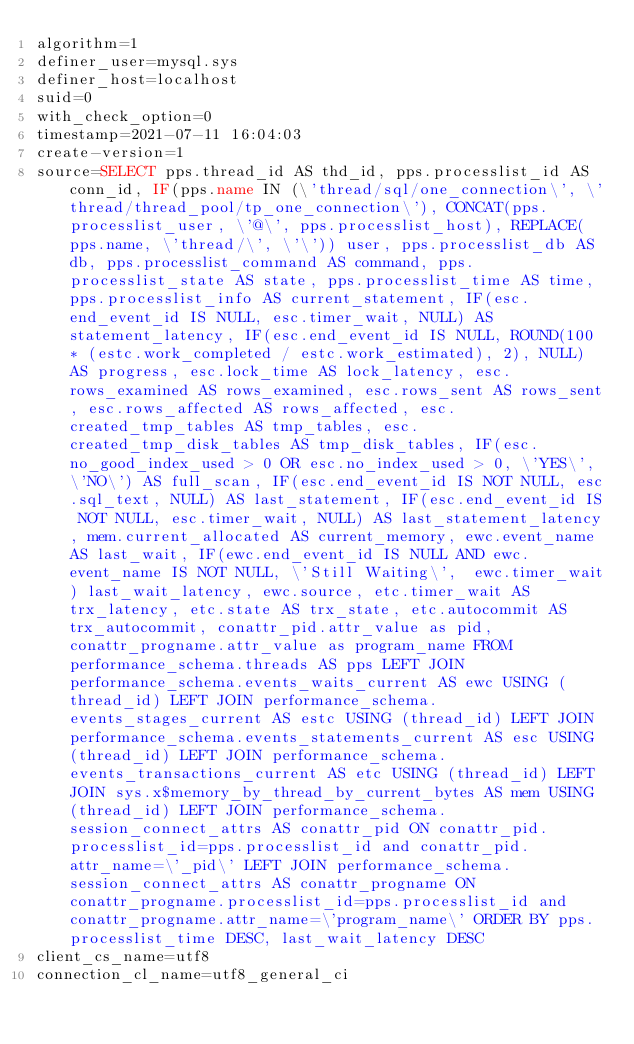Convert code to text. <code><loc_0><loc_0><loc_500><loc_500><_VisualBasic_>algorithm=1
definer_user=mysql.sys
definer_host=localhost
suid=0
with_check_option=0
timestamp=2021-07-11 16:04:03
create-version=1
source=SELECT pps.thread_id AS thd_id, pps.processlist_id AS conn_id, IF(pps.name IN (\'thread/sql/one_connection\', \'thread/thread_pool/tp_one_connection\'), CONCAT(pps.processlist_user, \'@\', pps.processlist_host), REPLACE(pps.name, \'thread/\', \'\')) user, pps.processlist_db AS db, pps.processlist_command AS command, pps.processlist_state AS state, pps.processlist_time AS time, pps.processlist_info AS current_statement, IF(esc.end_event_id IS NULL, esc.timer_wait, NULL) AS statement_latency, IF(esc.end_event_id IS NULL, ROUND(100 * (estc.work_completed / estc.work_estimated), 2), NULL) AS progress, esc.lock_time AS lock_latency, esc.rows_examined AS rows_examined, esc.rows_sent AS rows_sent, esc.rows_affected AS rows_affected, esc.created_tmp_tables AS tmp_tables, esc.created_tmp_disk_tables AS tmp_disk_tables, IF(esc.no_good_index_used > 0 OR esc.no_index_used > 0, \'YES\', \'NO\') AS full_scan, IF(esc.end_event_id IS NOT NULL, esc.sql_text, NULL) AS last_statement, IF(esc.end_event_id IS NOT NULL, esc.timer_wait, NULL) AS last_statement_latency, mem.current_allocated AS current_memory, ewc.event_name AS last_wait, IF(ewc.end_event_id IS NULL AND ewc.event_name IS NOT NULL, \'Still Waiting\',  ewc.timer_wait) last_wait_latency, ewc.source, etc.timer_wait AS trx_latency, etc.state AS trx_state, etc.autocommit AS trx_autocommit, conattr_pid.attr_value as pid, conattr_progname.attr_value as program_name FROM performance_schema.threads AS pps LEFT JOIN performance_schema.events_waits_current AS ewc USING (thread_id) LEFT JOIN performance_schema.events_stages_current AS estc USING (thread_id) LEFT JOIN performance_schema.events_statements_current AS esc USING (thread_id) LEFT JOIN performance_schema.events_transactions_current AS etc USING (thread_id) LEFT JOIN sys.x$memory_by_thread_by_current_bytes AS mem USING (thread_id) LEFT JOIN performance_schema.session_connect_attrs AS conattr_pid ON conattr_pid.processlist_id=pps.processlist_id and conattr_pid.attr_name=\'_pid\' LEFT JOIN performance_schema.session_connect_attrs AS conattr_progname ON conattr_progname.processlist_id=pps.processlist_id and conattr_progname.attr_name=\'program_name\' ORDER BY pps.processlist_time DESC, last_wait_latency DESC
client_cs_name=utf8
connection_cl_name=utf8_general_ci</code> 